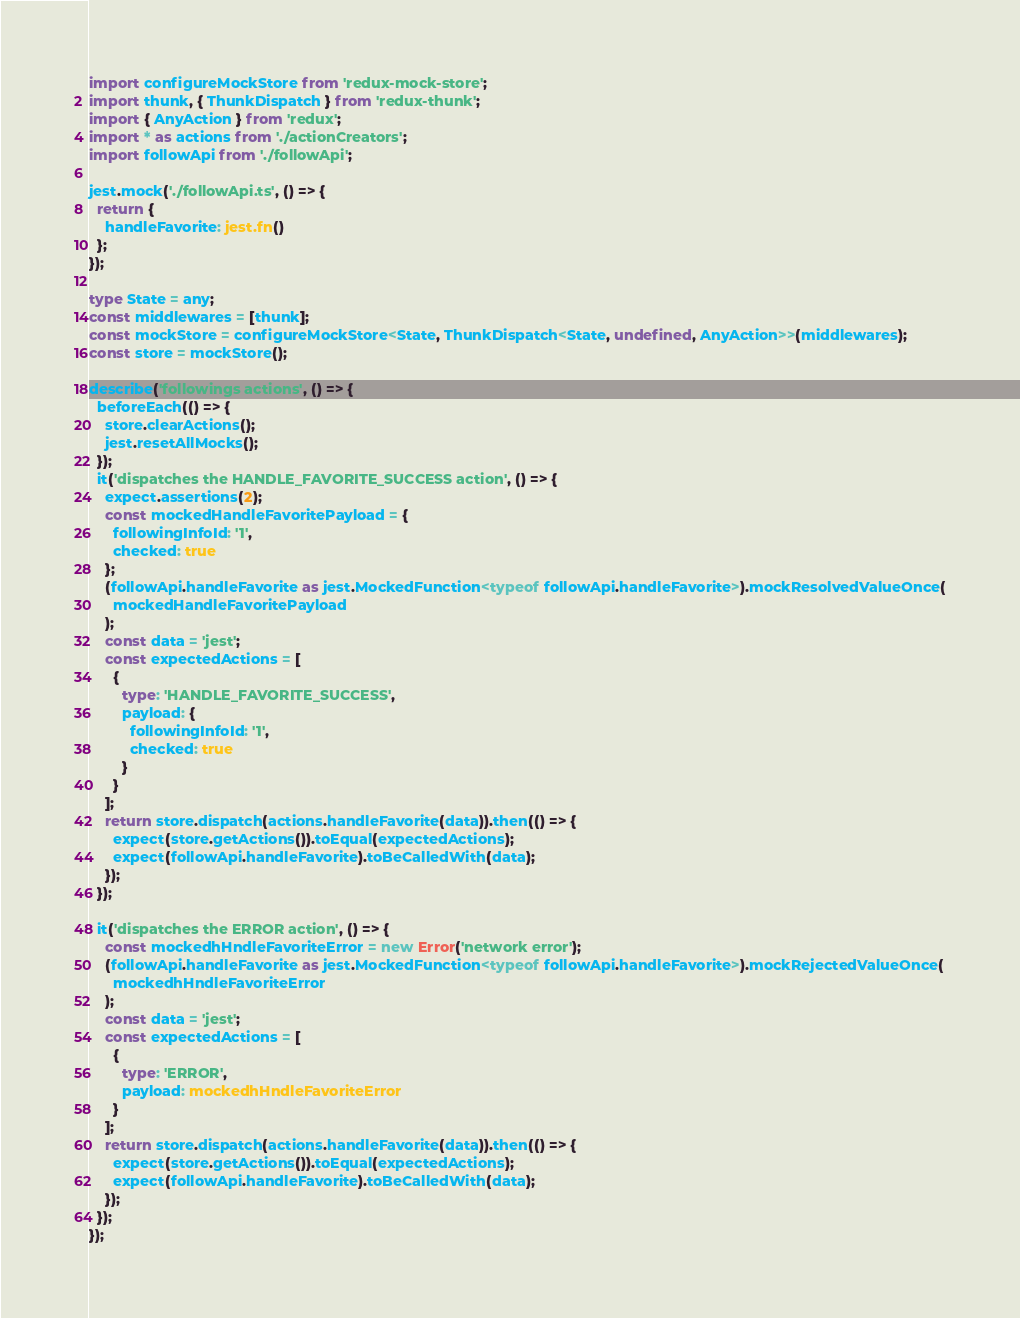<code> <loc_0><loc_0><loc_500><loc_500><_TypeScript_>import configureMockStore from 'redux-mock-store';
import thunk, { ThunkDispatch } from 'redux-thunk';
import { AnyAction } from 'redux';
import * as actions from './actionCreators';
import followApi from './followApi';

jest.mock('./followApi.ts', () => {
  return {
    handleFavorite: jest.fn()
  };
});

type State = any;
const middlewares = [thunk];
const mockStore = configureMockStore<State, ThunkDispatch<State, undefined, AnyAction>>(middlewares);
const store = mockStore();

describe('followings actions', () => {
  beforeEach(() => {
    store.clearActions();
    jest.resetAllMocks();
  });
  it('dispatches the HANDLE_FAVORITE_SUCCESS action', () => {
    expect.assertions(2);
    const mockedHandleFavoritePayload = {
      followingInfoId: '1',
      checked: true
    };
    (followApi.handleFavorite as jest.MockedFunction<typeof followApi.handleFavorite>).mockResolvedValueOnce(
      mockedHandleFavoritePayload
    );
    const data = 'jest';
    const expectedActions = [
      {
        type: 'HANDLE_FAVORITE_SUCCESS',
        payload: {
          followingInfoId: '1',
          checked: true
        }
      }
    ];
    return store.dispatch(actions.handleFavorite(data)).then(() => {
      expect(store.getActions()).toEqual(expectedActions);
      expect(followApi.handleFavorite).toBeCalledWith(data);
    });
  });

  it('dispatches the ERROR action', () => {
    const mockedhHndleFavoriteError = new Error('network error');
    (followApi.handleFavorite as jest.MockedFunction<typeof followApi.handleFavorite>).mockRejectedValueOnce(
      mockedhHndleFavoriteError
    );
    const data = 'jest';
    const expectedActions = [
      {
        type: 'ERROR',
        payload: mockedhHndleFavoriteError
      }
    ];
    return store.dispatch(actions.handleFavorite(data)).then(() => {
      expect(store.getActions()).toEqual(expectedActions);
      expect(followApi.handleFavorite).toBeCalledWith(data);
    });
  });
});
</code> 